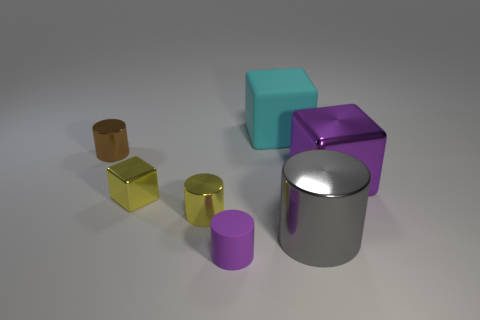Are there fewer cylinders in front of the big cyan matte block than tiny matte things left of the purple rubber cylinder?
Provide a succinct answer. No. What color is the tiny shiny cube?
Your answer should be compact. Yellow. There is a tiny object that is in front of the yellow shiny cylinder; are there any shiny objects in front of it?
Offer a very short reply. No. How many brown metal cylinders have the same size as the purple matte cylinder?
Your response must be concise. 1. What number of tiny purple rubber objects are behind the tiny object in front of the shiny cylinder to the right of the large cyan thing?
Give a very brief answer. 0. What number of objects are both on the right side of the tiny purple rubber cylinder and in front of the tiny yellow shiny cylinder?
Provide a succinct answer. 1. Is there any other thing that has the same color as the large shiny cube?
Offer a terse response. Yes. What number of rubber things are tiny yellow things or tiny blue cubes?
Offer a terse response. 0. There is a large block to the left of the metal block right of the block to the left of the big cyan thing; what is its material?
Offer a very short reply. Rubber. There is a cube that is right of the rubber thing that is behind the brown metallic object; what is its material?
Provide a succinct answer. Metal. 